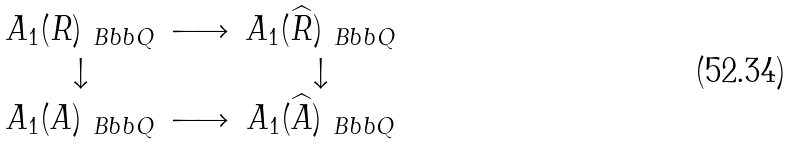Convert formula to latex. <formula><loc_0><loc_0><loc_500><loc_500>\begin{array} { c c c } A _ { 1 } ( R ) _ { \ B b b Q } & \longrightarrow & A _ { 1 } ( \widehat { R } ) _ { \ B b b Q } \\ \downarrow & & \downarrow \\ A _ { 1 } ( A ) _ { \ B b b Q } & \longrightarrow & A _ { 1 } ( \widehat { A } ) _ { \ B b b Q } \end{array}</formula> 